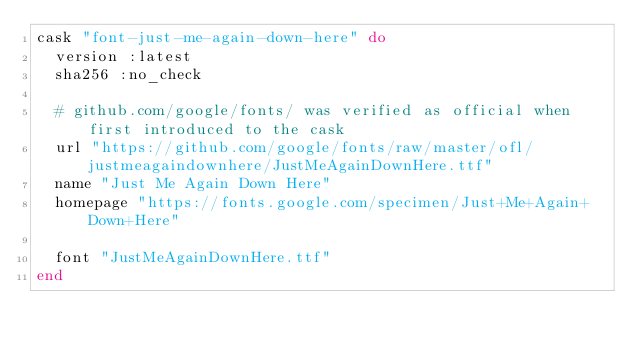<code> <loc_0><loc_0><loc_500><loc_500><_Ruby_>cask "font-just-me-again-down-here" do
  version :latest
  sha256 :no_check

  # github.com/google/fonts/ was verified as official when first introduced to the cask
  url "https://github.com/google/fonts/raw/master/ofl/justmeagaindownhere/JustMeAgainDownHere.ttf"
  name "Just Me Again Down Here"
  homepage "https://fonts.google.com/specimen/Just+Me+Again+Down+Here"

  font "JustMeAgainDownHere.ttf"
end
</code> 